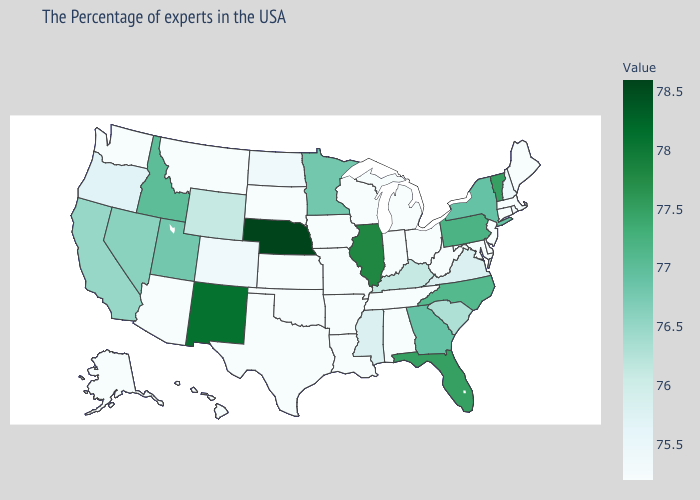Does Mississippi have a lower value than Washington?
Quick response, please. No. Is the legend a continuous bar?
Give a very brief answer. Yes. Does Utah have a higher value than Oregon?
Keep it brief. Yes. Does Nebraska have the highest value in the USA?
Answer briefly. Yes. Does North Carolina have a lower value than Illinois?
Keep it brief. Yes. 